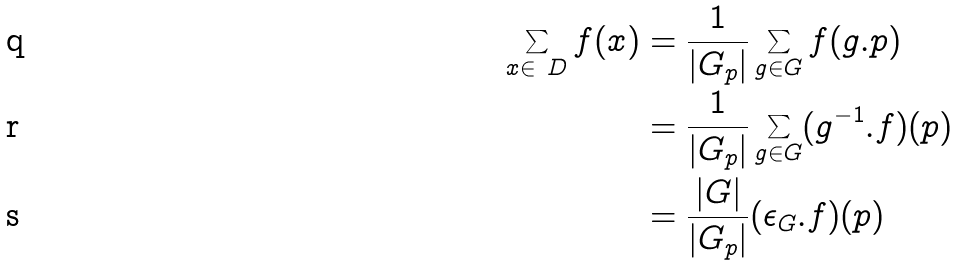<formula> <loc_0><loc_0><loc_500><loc_500>\sum _ { x \in \ D } f ( x ) & = \frac { 1 } { | G _ { p } | } \sum _ { g \in G } f ( g . p ) \\ & = \frac { 1 } { | G _ { p } | } \sum _ { g \in G } ( g ^ { - 1 } . f ) ( p ) \\ & = \frac { | G | } { | G _ { p } | } ( \epsilon _ { G } . f ) ( p )</formula> 